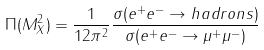<formula> <loc_0><loc_0><loc_500><loc_500>\Pi ( M _ { X } ^ { 2 } ) = \frac { 1 } { 1 2 \pi ^ { 2 } } \frac { \sigma ( e ^ { + } e ^ { - } \rightarrow h a d r o n s ) } { \sigma ( e ^ { + } e ^ { - } \rightarrow \mu ^ { + } \mu ^ { - } ) }</formula> 